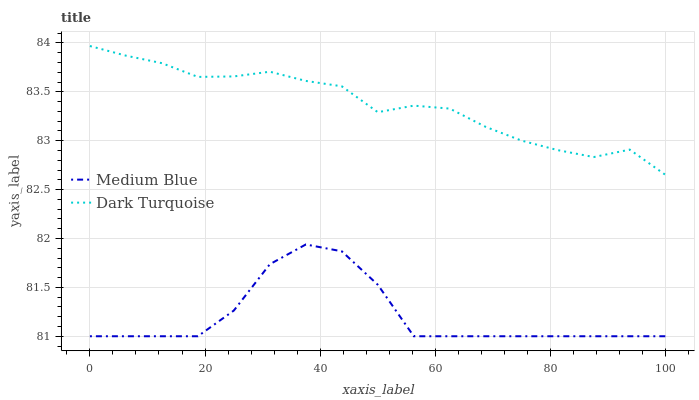Does Medium Blue have the minimum area under the curve?
Answer yes or no. Yes. Does Dark Turquoise have the maximum area under the curve?
Answer yes or no. Yes. Does Medium Blue have the maximum area under the curve?
Answer yes or no. No. Is Dark Turquoise the smoothest?
Answer yes or no. Yes. Is Medium Blue the roughest?
Answer yes or no. Yes. Is Medium Blue the smoothest?
Answer yes or no. No. Does Medium Blue have the lowest value?
Answer yes or no. Yes. Does Dark Turquoise have the highest value?
Answer yes or no. Yes. Does Medium Blue have the highest value?
Answer yes or no. No. Is Medium Blue less than Dark Turquoise?
Answer yes or no. Yes. Is Dark Turquoise greater than Medium Blue?
Answer yes or no. Yes. Does Medium Blue intersect Dark Turquoise?
Answer yes or no. No. 